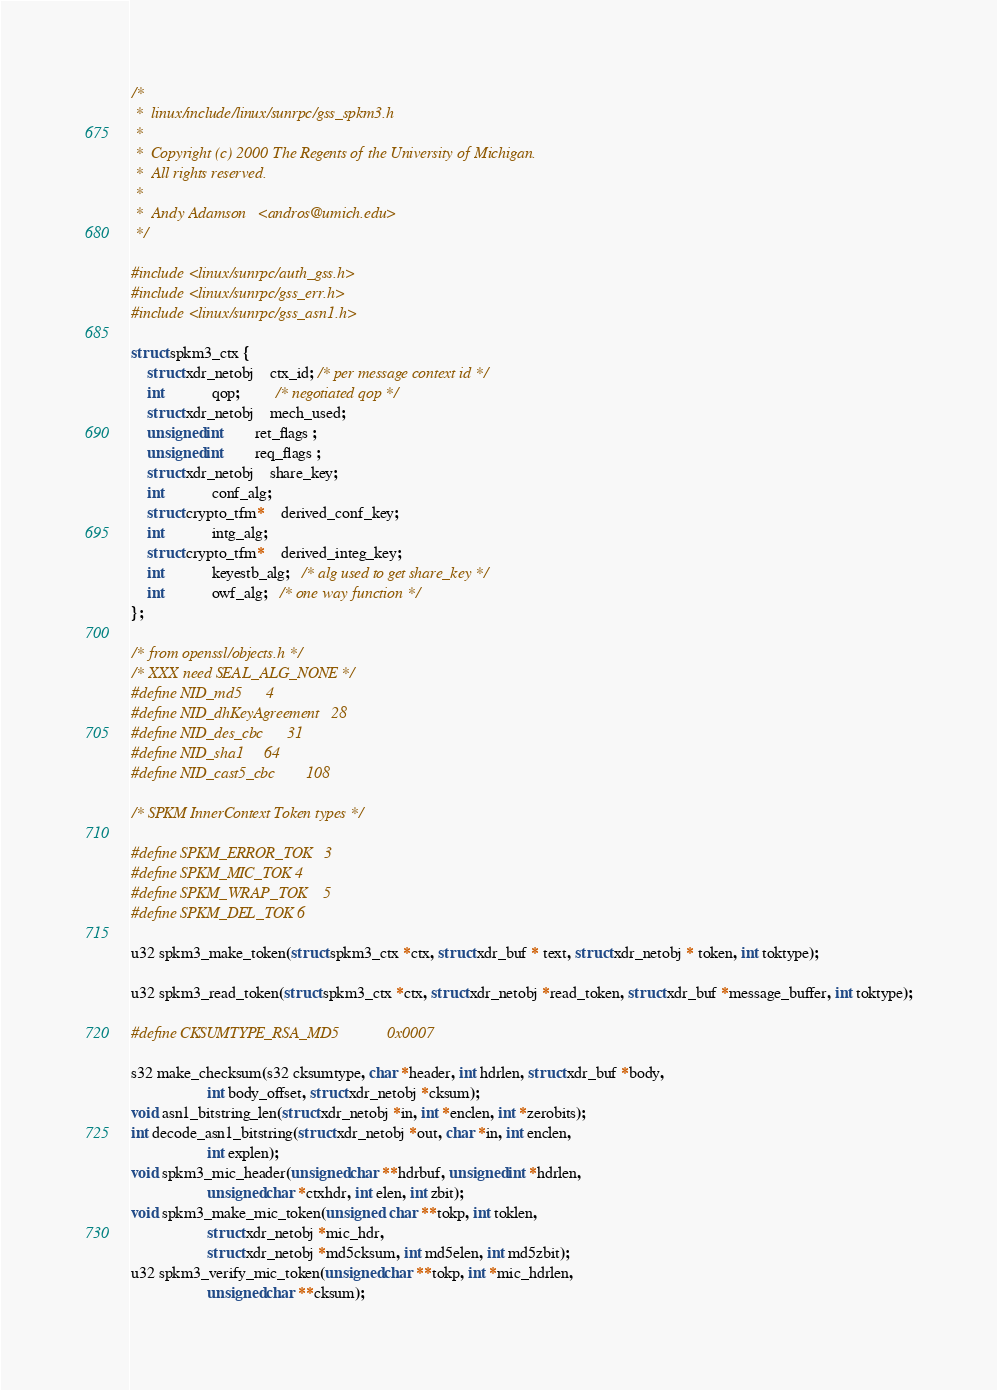Convert code to text. <code><loc_0><loc_0><loc_500><loc_500><_C_>/*
 *  linux/include/linux/sunrpc/gss_spkm3.h
 *
 *  Copyright (c) 2000 The Regents of the University of Michigan.
 *  All rights reserved.
 *
 *  Andy Adamson   <andros@umich.edu>
 */

#include <linux/sunrpc/auth_gss.h>
#include <linux/sunrpc/gss_err.h>
#include <linux/sunrpc/gss_asn1.h>

struct spkm3_ctx {
	struct xdr_netobj	ctx_id; /* per message context id */
	int			qop;         /* negotiated qop */
	struct xdr_netobj	mech_used;
	unsigned int		ret_flags ;
	unsigned int		req_flags ;
	struct xdr_netobj	share_key;
	int			conf_alg;
	struct crypto_tfm*	derived_conf_key;
	int			intg_alg;
	struct crypto_tfm*	derived_integ_key;
	int			keyestb_alg;   /* alg used to get share_key */
	int			owf_alg;   /* one way function */
};

/* from openssl/objects.h */
/* XXX need SEAL_ALG_NONE */
#define NID_md5		4
#define NID_dhKeyAgreement	28 
#define NID_des_cbc		31 
#define NID_sha1		64
#define NID_cast5_cbc		108

/* SPKM InnerContext Token types */

#define SPKM_ERROR_TOK	3
#define SPKM_MIC_TOK	4
#define SPKM_WRAP_TOK	5
#define SPKM_DEL_TOK	6

u32 spkm3_make_token(struct spkm3_ctx *ctx, struct xdr_buf * text, struct xdr_netobj * token, int toktype);

u32 spkm3_read_token(struct spkm3_ctx *ctx, struct xdr_netobj *read_token, struct xdr_buf *message_buffer, int toktype);

#define CKSUMTYPE_RSA_MD5            0x0007

s32 make_checksum(s32 cksumtype, char *header, int hdrlen, struct xdr_buf *body,
                   int body_offset, struct xdr_netobj *cksum);
void asn1_bitstring_len(struct xdr_netobj *in, int *enclen, int *zerobits);
int decode_asn1_bitstring(struct xdr_netobj *out, char *in, int enclen, 
                   int explen);
void spkm3_mic_header(unsigned char **hdrbuf, unsigned int *hdrlen, 
                   unsigned char *ctxhdr, int elen, int zbit);
void spkm3_make_mic_token(unsigned  char **tokp, int toklen, 
                   struct xdr_netobj *mic_hdr,
                   struct xdr_netobj *md5cksum, int md5elen, int md5zbit);
u32 spkm3_verify_mic_token(unsigned char **tokp, int *mic_hdrlen, 
                   unsigned char **cksum);
</code> 